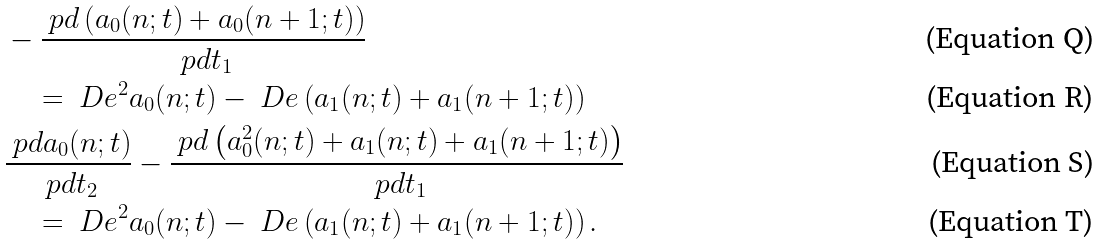<formula> <loc_0><loc_0><loc_500><loc_500>& - \frac { \ p d \left ( a _ { 0 } ( n ; t ) + a _ { 0 } ( n + 1 ; t ) \right ) } { \ p d t _ { 1 } } \\ & \quad = \ D e ^ { 2 } a _ { 0 } ( n ; t ) - \ D e \left ( a _ { 1 } ( n ; t ) + a _ { 1 } ( n + 1 ; t ) \right ) \\ & \frac { \ p d a _ { 0 } ( n ; t ) } { \ p d t _ { 2 } } - \frac { \ p d \left ( a _ { 0 } ^ { 2 } ( n ; t ) + a _ { 1 } ( n ; t ) + a _ { 1 } ( n + 1 ; t ) \right ) } { \ p d t _ { 1 } } \\ & \quad = \ D e ^ { 2 } a _ { 0 } ( n ; t ) - \ D e \left ( a _ { 1 } ( n ; t ) + a _ { 1 } ( n + 1 ; t ) \right ) .</formula> 